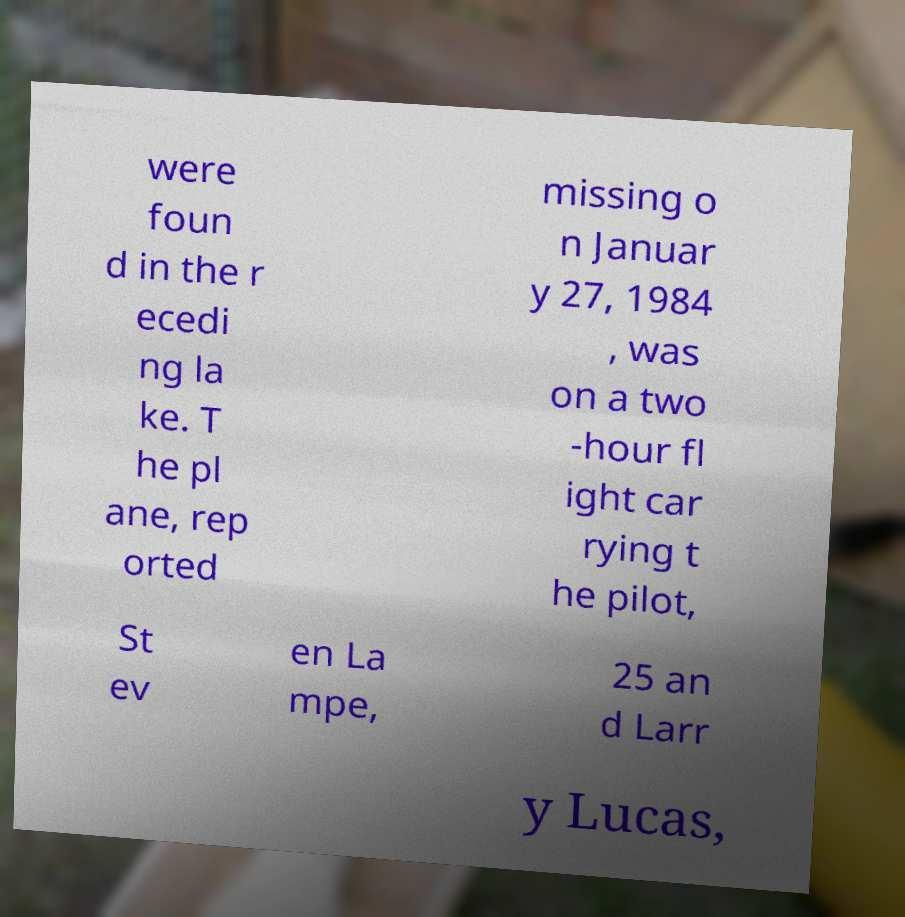There's text embedded in this image that I need extracted. Can you transcribe it verbatim? were foun d in the r ecedi ng la ke. T he pl ane, rep orted missing o n Januar y 27, 1984 , was on a two -hour fl ight car rying t he pilot, St ev en La mpe, 25 an d Larr y Lucas, 